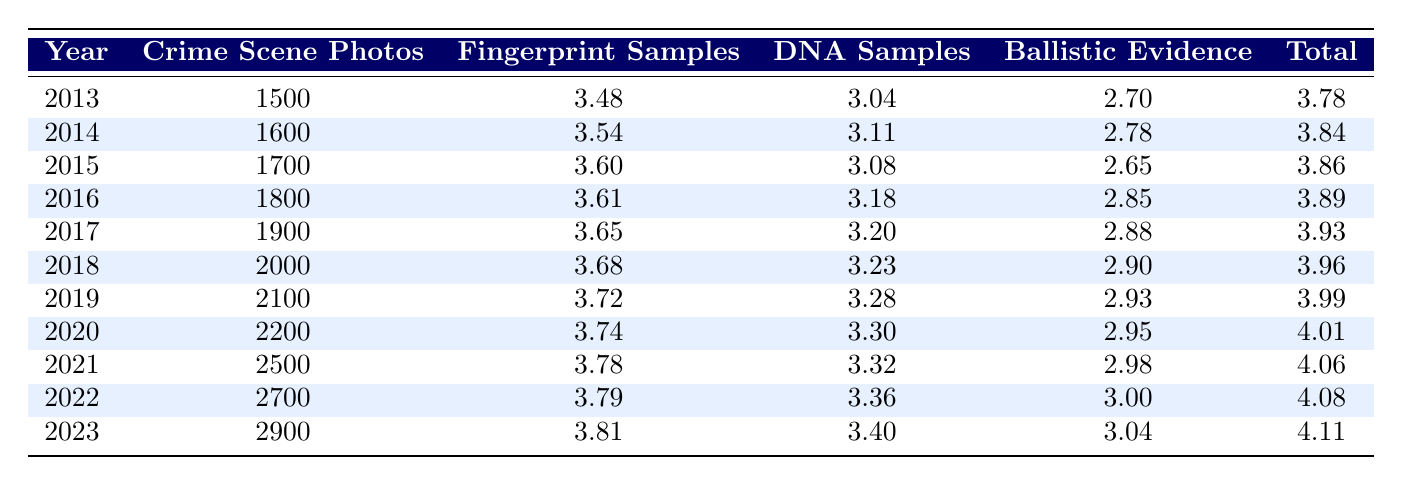What year saw the highest number of crime scene photos? The table shows the number of crime scene photos for each year from 2013 to 2023. Scanning through the years, 2023 has the highest value of 2900, which is the largest number represented in the table.
Answer: 2023 What was the total number of DNA samples collected in 2016 and 2017? Referring to the table, the count of DNA samples for 2016 is 1500, and for 2017 it is 1600. Adding these values together gives 1500 + 1600 = 3100.
Answer: 3100 In which year did the number of fingerprint samples first exceed 4500? Looking at the fingerprint samples for each year, the number first exceeds 4500 in 2017, where there are 4500 samples. The prior year, 2016, records 4100.
Answer: 2017 Is the average number of ballistic evidence collected in 2019 and 2020 more than 850? For 2019, the number of ballistic evidence is 850, and for 2020 it is 900. To find the average, we add these two values (850 + 900 = 1750) and then divide by 2, giving us 1750/2 = 875. Since 875 is greater than 850, the statement is true.
Answer: Yes What is the difference in the total number of samples (fingerprints + DNA + ballistic) between the years 2018 and 2022? For 2018, the totals are fingerprint samples (4800) + DNA samples (1700) + ballistic evidence (800) which equals 4800 + 1700 + 800 = 6300. For 2022, the totals are fingerprint samples (6200) + DNA samples (2300) + ballistic evidence (1000) summing up to 6200 + 2300 + 1000 = 9500. The difference is 9500 - 6300 = 3200.
Answer: 3200 